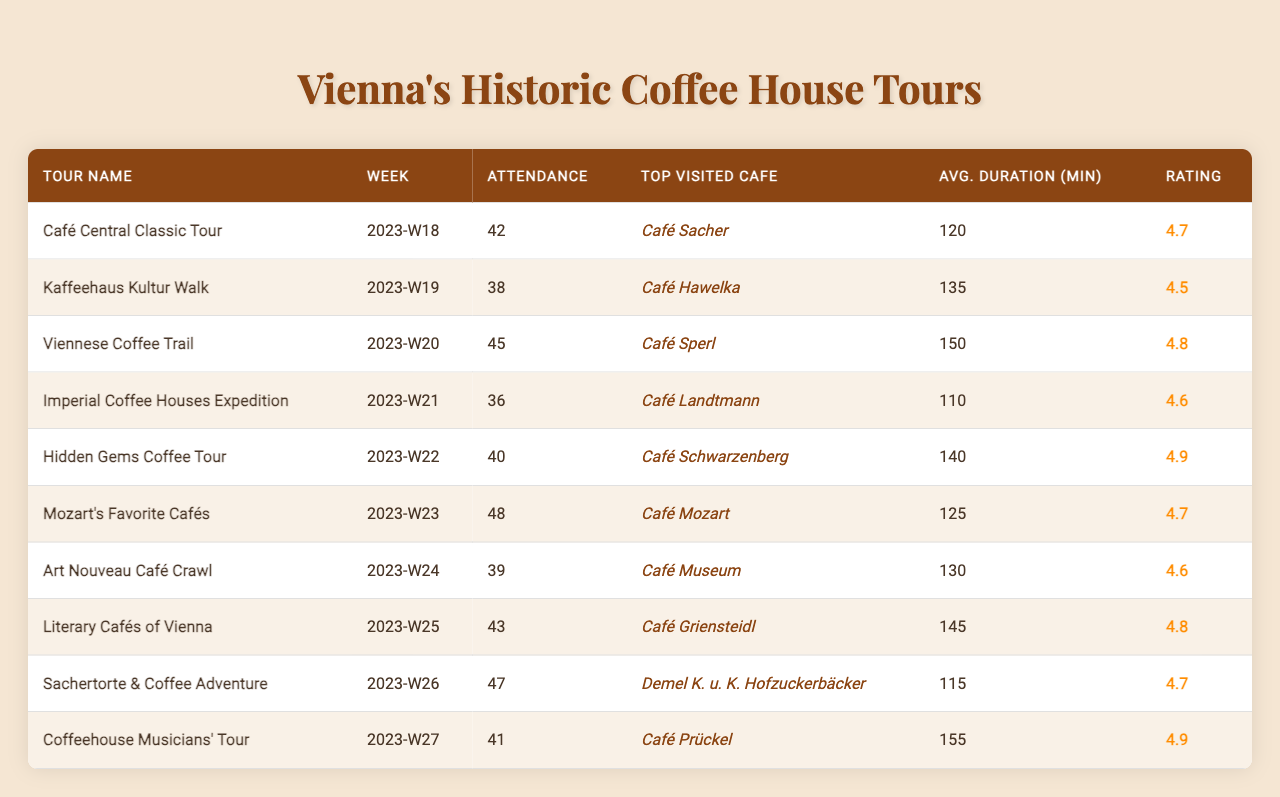What is the highest attendance recorded for a tour? By scanning the attendance column, the highest value is 48, which corresponds to the "Mozart's Favorite Cafés" tour.
Answer: 48 Which tour has the lowest customer rating? Reviewing the customer ratings, the "Kaffeehaus Kultur Walk" has the lowest rating at 4.5.
Answer: 4.5 What is the average attendance across all tours? To find the average, sum all attendance figures: (42 + 38 + 45 + 36 + 40 + 48 + 39 + 43 + 47 + 41) = 419. There are 10 tours, so the average is 419/10 = 41.9.
Answer: 41.9 Which tour had 43 attendees and what was its rating? The "Café Griensteidl" tour had 43 attendees in week 25 and its customer rating is 4.8.
Answer: 4.8 How many tours had an attendance of 40 or more? The tours with an attendance of 40 or more are: "Café Central Classic Tour," "Viennese Coffee Trail," "Hidden Gems Coffee Tour," "Mozart's Favorite Cafés," "Sachertorte & Coffee Adventure," and "Coffeehouse Musicians' Tour," totaling 6 tours.
Answer: 6 What was the average duration of tours that had a customer rating of 4.8? The tours with a rating of 4.8 are: "Viennese Coffee Trail," "Literary Cafés of Vienna," and "Mozart's Favorite Cafés." Their durations are 150, 145, and 125 minutes. The average duration is (150 + 145 + 125) / 3 = 140.
Answer: 140 Is there a tour that has both high attendance and a high rating? Yes, the "Mozart's Favorite Cafés" tour has an attendance of 48 and a rating of 4.9, indicating both high attendance and a high rating.
Answer: Yes Which week had the highest attendance and what was the name of the tour? The highest attendance of 48 occurred in week 23 for the "Mozart's Favorite Cafés" tour.
Answer: Mozart's Favorite Cafés Calculate the difference in average duration between the tour with the highest rating and the tour with the lowest rating. The highest rating is 4.9 (from "Mozart's Favorite Cafés") with a duration of 125 minutes, and the lowest is 4.5 (from "Kaffeehaus Kultur Walk") with a duration of 135 minutes. The difference is 135 - 125 = 10 minutes.
Answer: 10 minutes What is the most popular café visited according to the data? "Café Sacher" is the top visited café for the "Café Central Classic Tour," indicating it is popular among tour participants.
Answer: Café Sacher Which week had the highest attendance, and what was the average duration of tours that week? Week 23 had the highest attendance of 48 people for "Mozart's Favorite Cafés," with an average duration of 125 minutes for that tour.
Answer: 125 minutes 